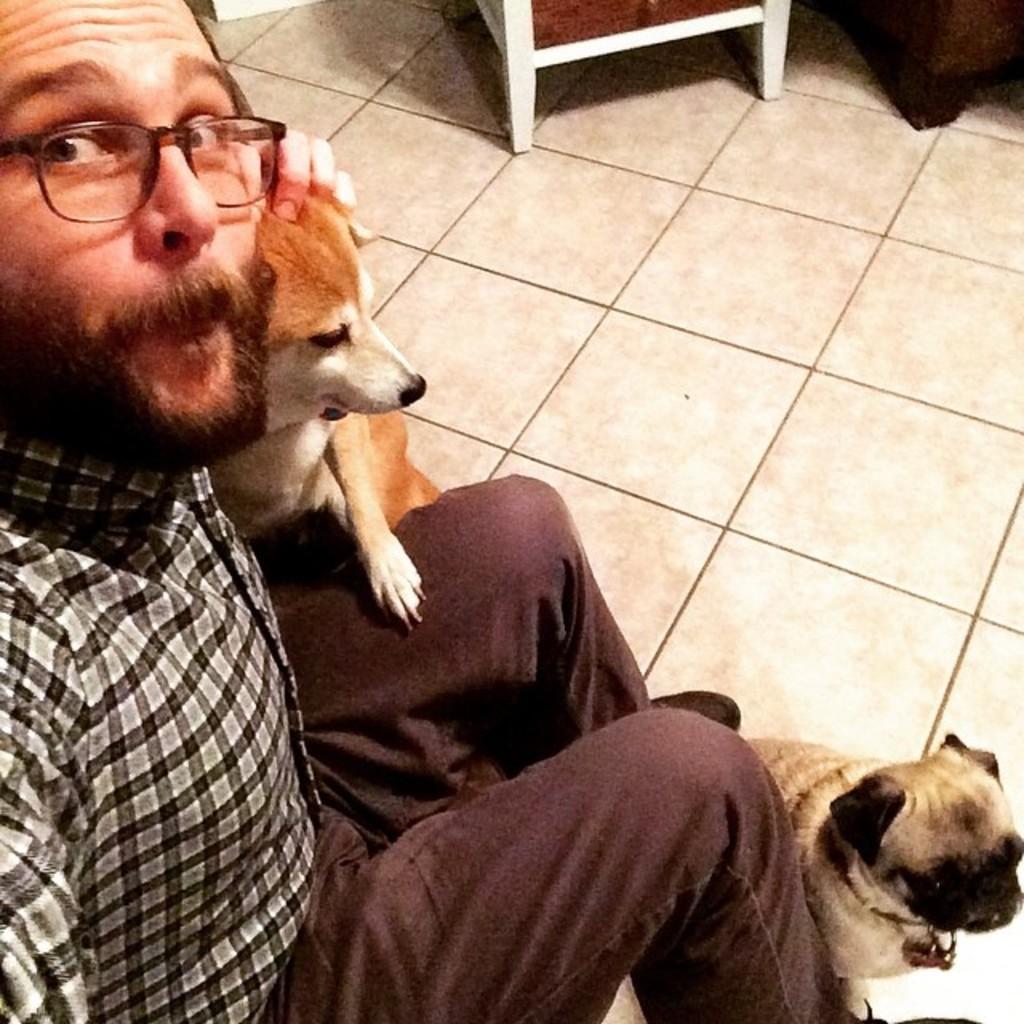In one or two sentences, can you explain what this image depicts? In this picture we can see man wore spectacle holding dog with his hand and other dog is at his legs and in background we can see floor. 